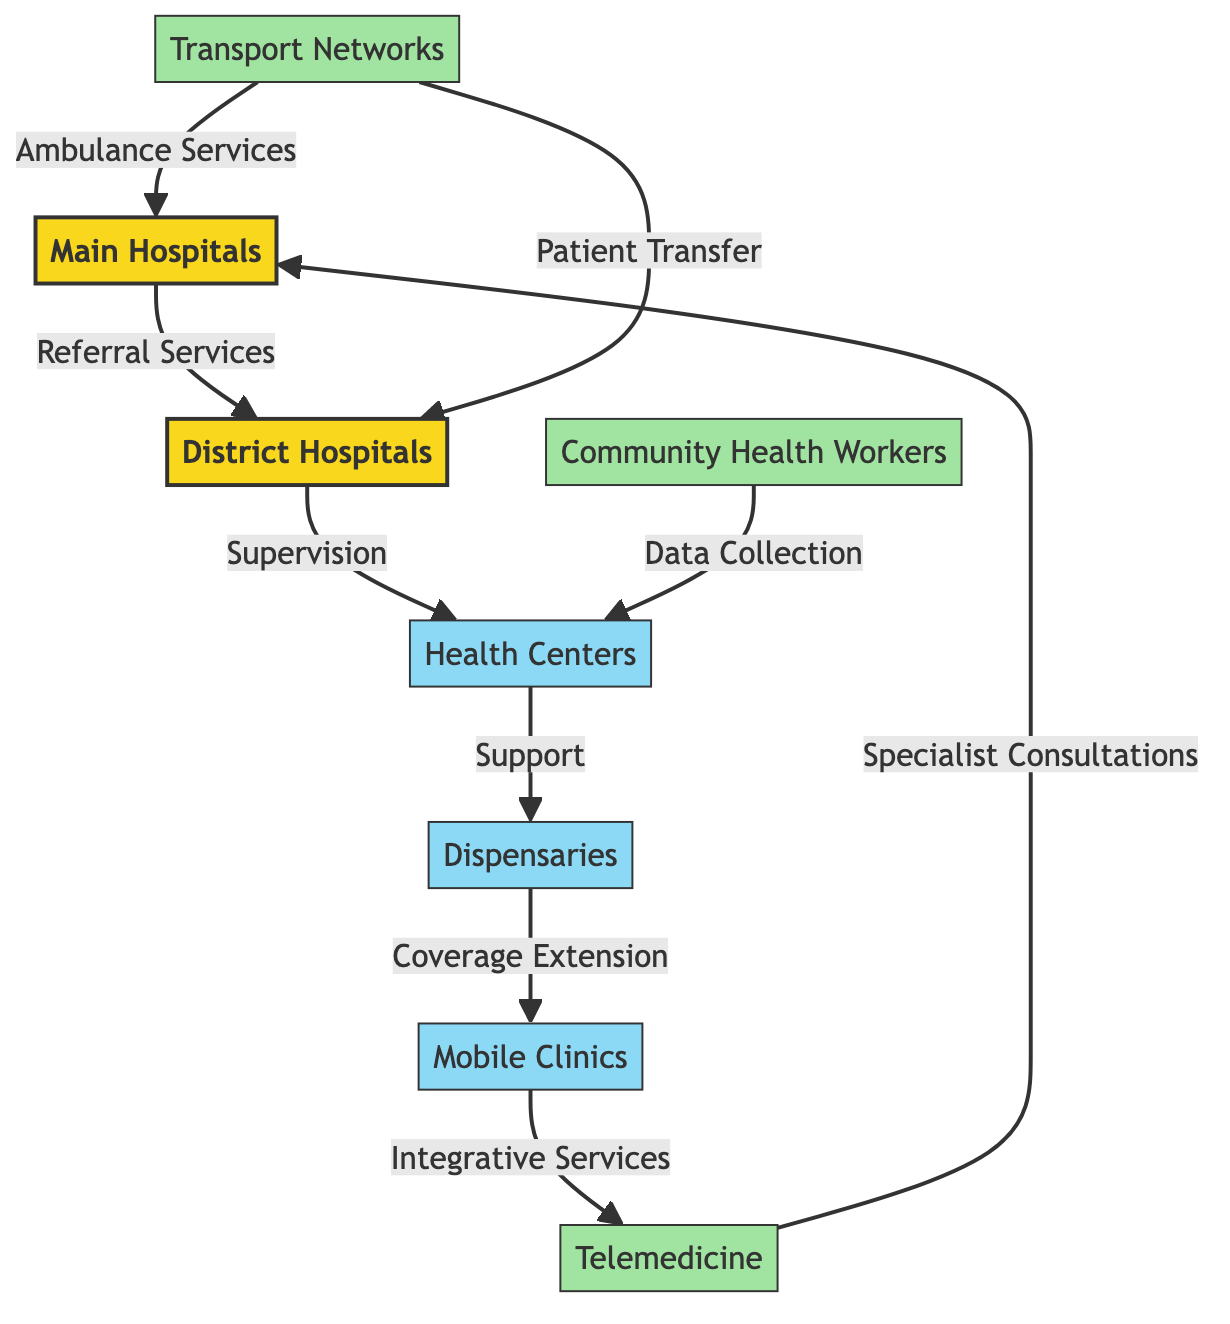What are the main types of healthcare facilities shown in the diagram? The diagram includes Main Hospitals, District Hospitals, Health Centers, Dispensaries, and Mobile Clinics. These are clearly indicated as the primary nodes in the flowchart.
Answer: Main Hospitals, District Hospitals, Health Centers, Dispensaries, Mobile Clinics Which node connects Community Health Workers to Health Centers? The diagram shows Community Health Workers (CHW) connecting to Health Centers (HC) through the data collection relationship, indicated by the arrow between them.
Answer: Data Collection How many total types of healthcare facilities are there in the diagram? Counting the distinct nodes, we find Main Hospitals, District Hospitals, Health Centers, Dispensaries, and Mobile Clinics, which totals five types of healthcare facilities.
Answer: Five What is the relationship between District Hospitals and Health Centers? According to the diagram, the relationship is that District Hospitals supervise Health Centers, which is represented by an arrow pointing from DH to HC labeled "Supervision".
Answer: Supervision Which healthcare facility is directly connected to Telemedicine? The diagram specifies that Telemedicine (TM) is connected to Main Hospitals (MH) with a relationship described as "Specialist Consultations". This indicates that TM provides services to MH.
Answer: Main Hospitals What role do Mobile Clinics play in the healthcare network? Mobile Clinics (MC) have a role of "Integrative Services" connecting them to Telemedicine (TM) as shown by the arrow leading from MC to TM. This indicates that they provide services that integrate with telemedicine.
Answer: Integrative Services How many connections lead into Main Hospitals from other nodes? Analyzing the diagram, Main Hospitals (MH) have two connections leading to them: one from District Hospitals (DH) and the other from Telemedicine (TM) through the relationships shown.
Answer: Two What is the nature of the connection between Transport Networks and Ambulance Services? The connection reflects that Transport Networks (TN) provide "Ambulance Services" leading into Main Hospitals (MH), as illustrated in the diagram.
Answer: Ambulance Services What type of support do Health Centers receive from District Hospitals? The diagram specifies that Health Centers (HC) receive supervision from District Hospitals (DH), illustrating the hierarchical support structure within healthcare facilities.
Answer: Supervision 